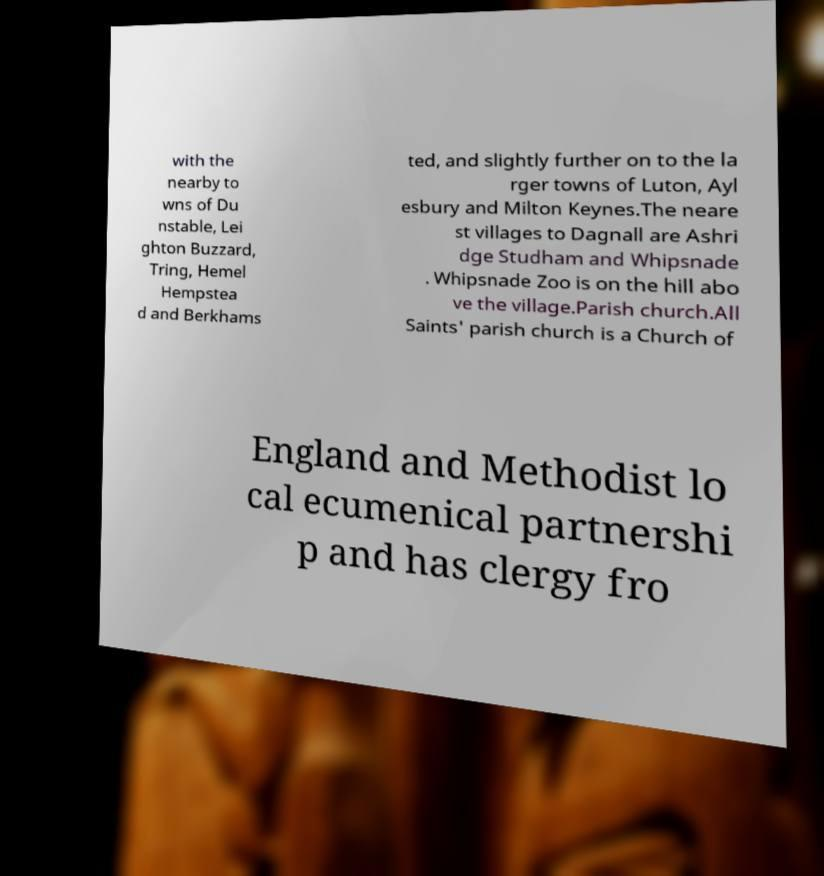Please identify and transcribe the text found in this image. with the nearby to wns of Du nstable, Lei ghton Buzzard, Tring, Hemel Hempstea d and Berkhams ted, and slightly further on to the la rger towns of Luton, Ayl esbury and Milton Keynes.The neare st villages to Dagnall are Ashri dge Studham and Whipsnade . Whipsnade Zoo is on the hill abo ve the village.Parish church.All Saints' parish church is a Church of England and Methodist lo cal ecumenical partnershi p and has clergy fro 